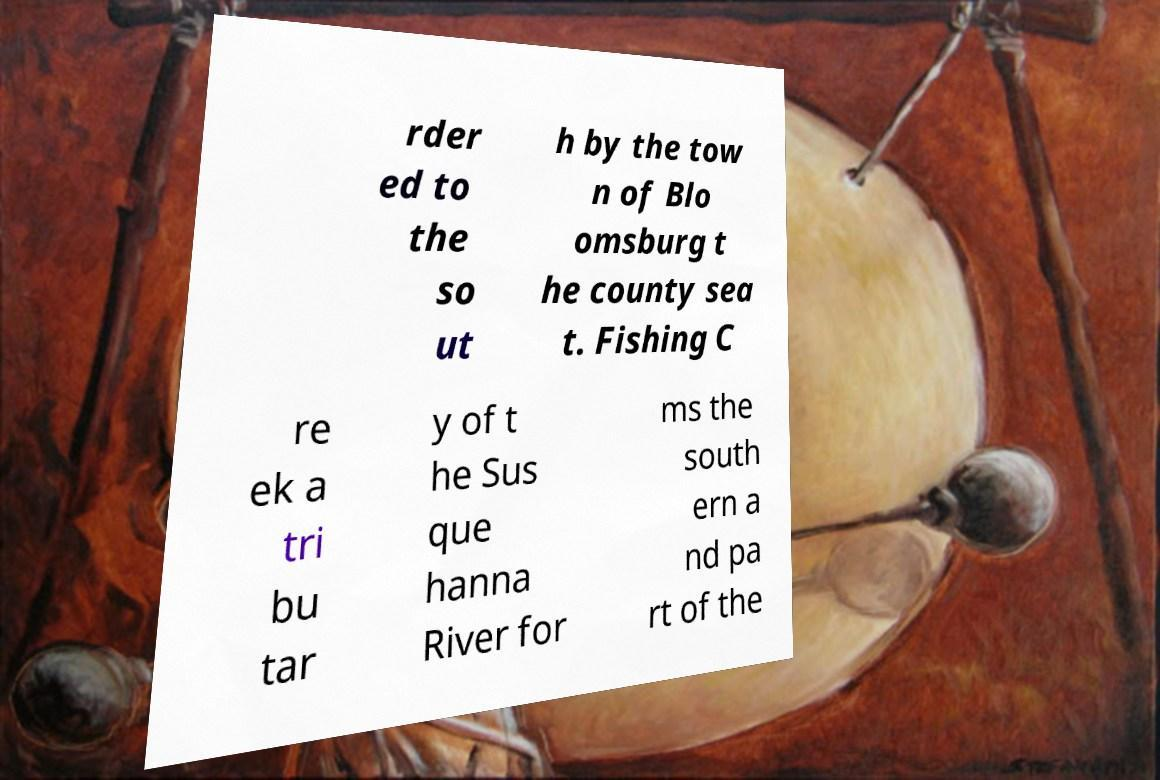Can you read and provide the text displayed in the image?This photo seems to have some interesting text. Can you extract and type it out for me? rder ed to the so ut h by the tow n of Blo omsburg t he county sea t. Fishing C re ek a tri bu tar y of t he Sus que hanna River for ms the south ern a nd pa rt of the 